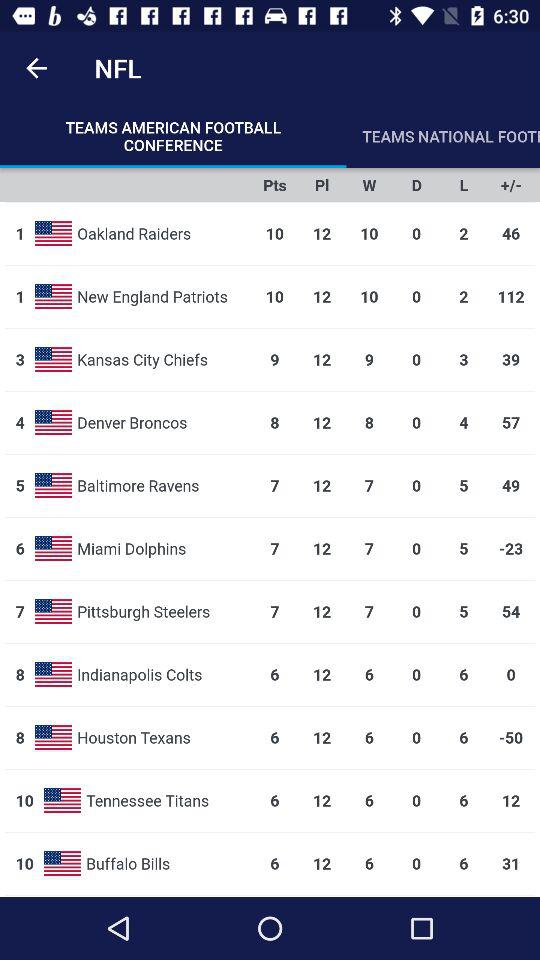What is the point of the Oakland Raiders? The point of the Oakland Raiders is 10. 